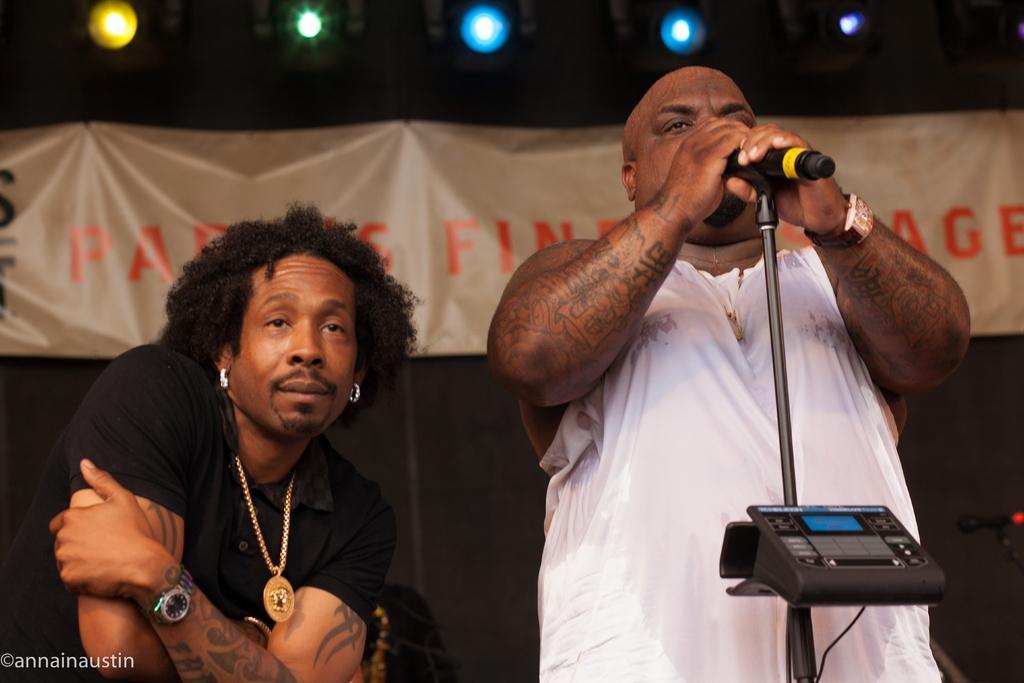Can you describe this image briefly? Two persons are there and this person standing and holding microphone with stand. On the background we can see banner and focusing lights. 